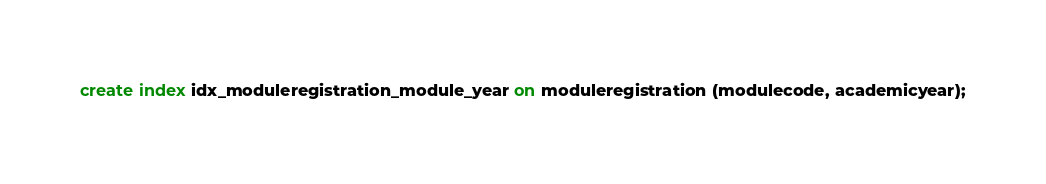Convert code to text. <code><loc_0><loc_0><loc_500><loc_500><_SQL_>create index idx_moduleregistration_module_year on moduleregistration (modulecode, academicyear);
</code> 